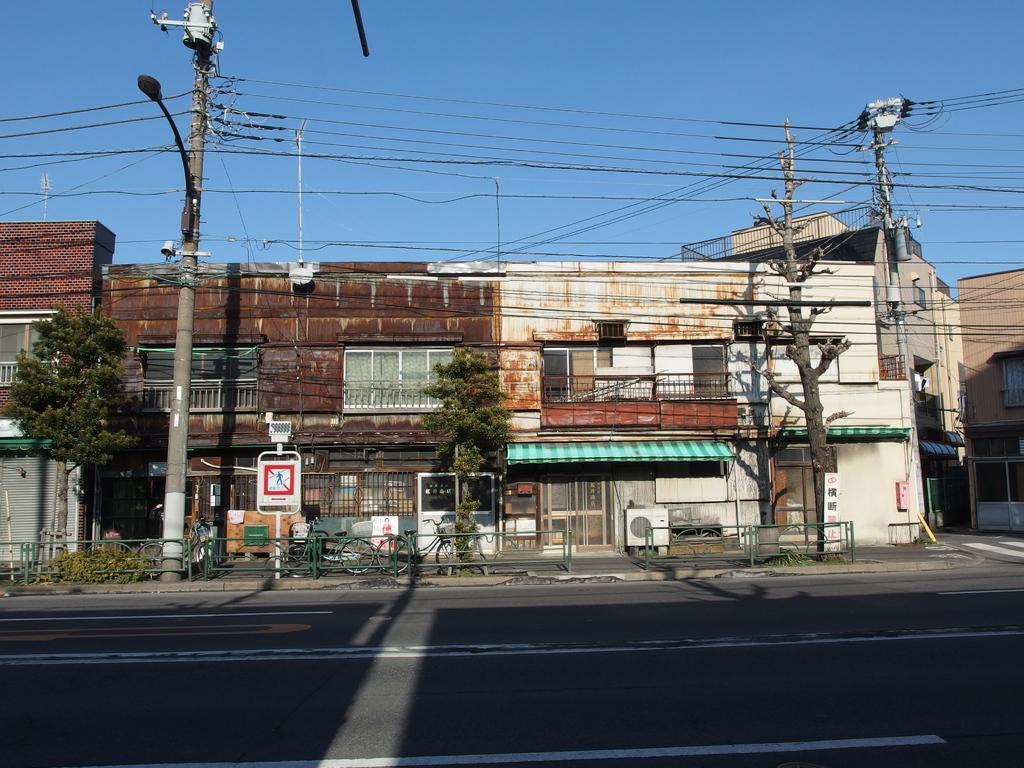Describe this image in one or two sentences. In this image we can see some buildings with windows. We can also see a road, some bicycles parked on the footpath, an air conditioner, a sign board, an utility pole with wires, the bark of a tree, some shutters, a tree and the sky which looks cloudy. 